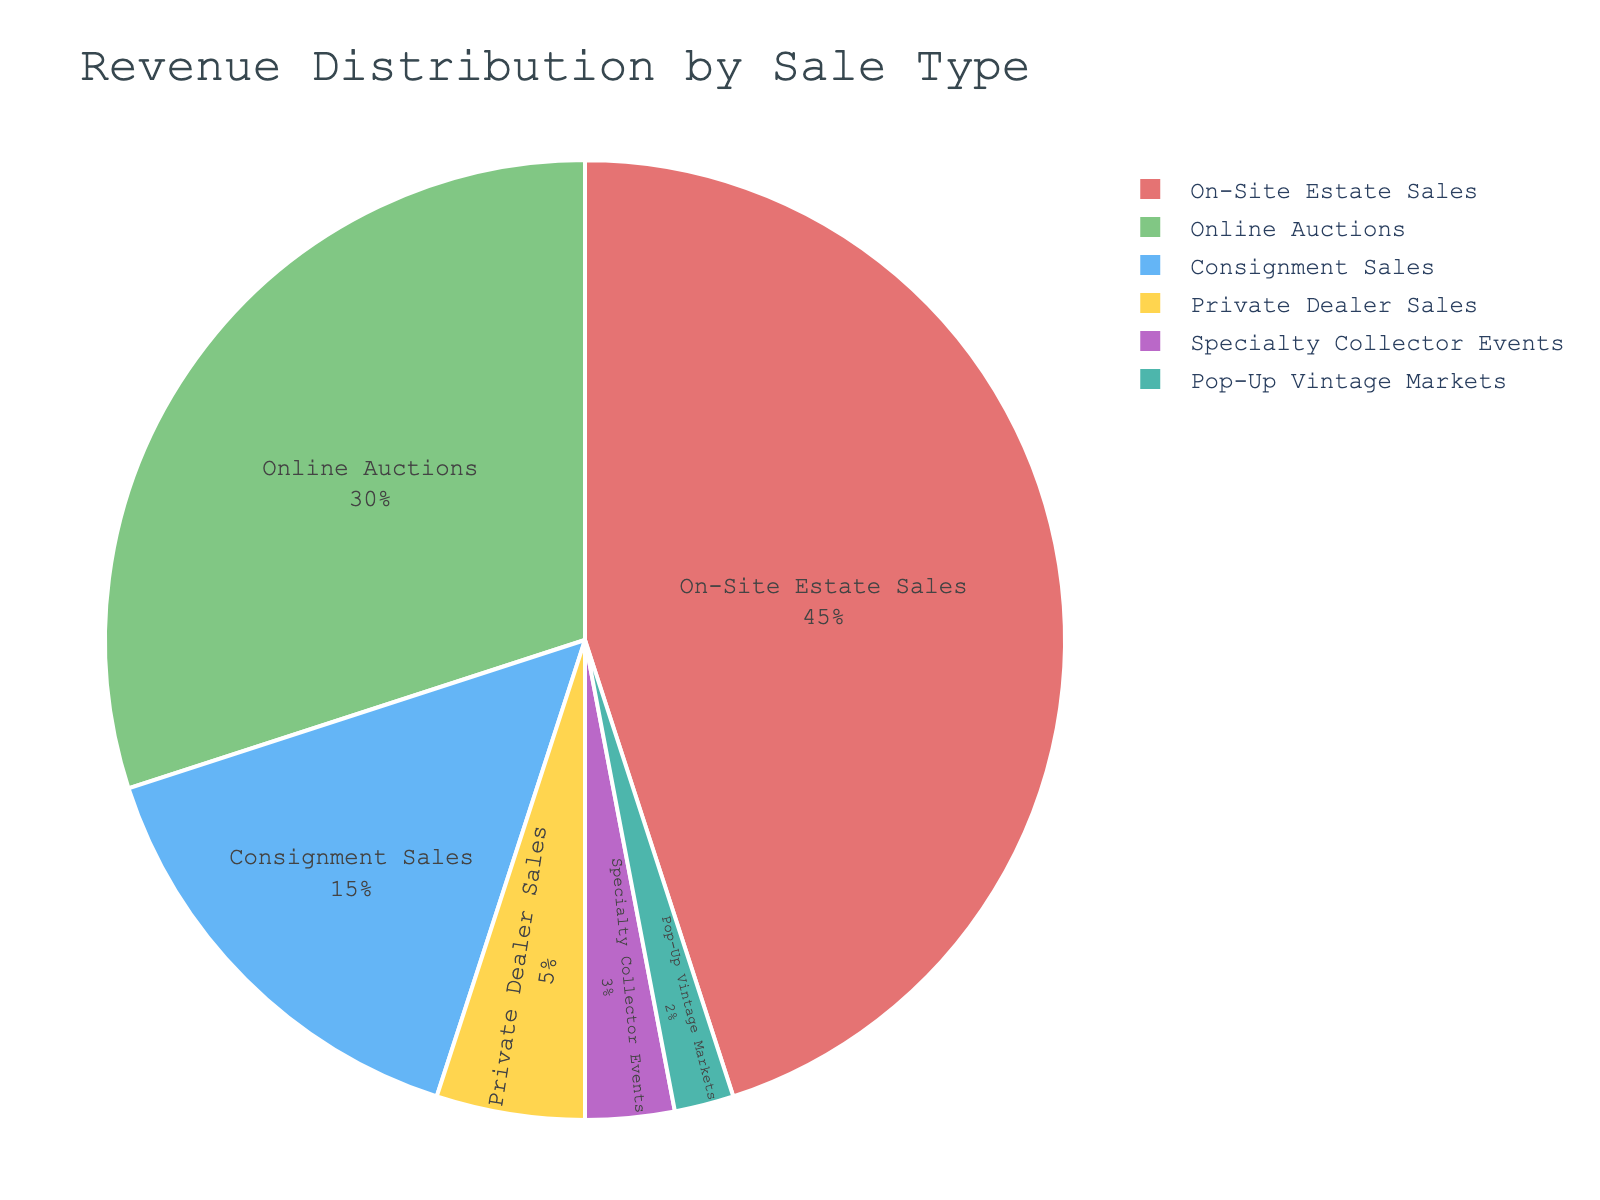Which sale type generates the highest revenue percentage? The figure shows that "On-Site Estate Sales" occupies the largest portion of the pie chart.
Answer: On-Site Estate Sales What is the combined revenue percentage of Consignment Sales and Private Dealer Sales? Consignment Sales accounts for 15% and Private Dealer Sales for 5%. Adding them together: 15% + 5% = 20%.
Answer: 20% Which sale type has a greater revenue percentage, Online Auctions or Specialty Collector Events, and by how much? Online Auctions account for 30%, whereas Specialty Collector Events account for 3%. The difference is 30% - 3% = 27%.
Answer: Online Auctions by 27% How much more revenue percentage do On-Site Estate Sales generate compared to Pop-Up Vintage Markets? On-Site Estate Sales generate 45% and Pop-Up Vintage Markets generate 2%. The difference is 45% - 2% = 43%.
Answer: 43% What is the total revenue percentage of the three smallest revenue sources? The smallest revenue sources are Pop-Up Vintage Markets (2%), Specialty Collector Events (3%), and Private Dealer Sales (5%). Adding them: 2% + 3% + 5% = 10%.
Answer: 10% Which color represents Online Auctions? The segment representing Online Auctions is shaded in green.
Answer: Green If you were to remove the revenue from Specialty Collector Events and Pop-Up Vintage Markets, what would be the remaining total revenue percentage? Specialty Collector Events and Pop-Up Vintage Markets contribute 3% and 2%, respectively. The total percentage is 100%. Removing these two gives: 100% - 3% - 2% = 95%.
Answer: 95% Is the revenue percentage generated by Consignment Sales greater than that of Private Dealer Sales? Consignment Sales generate 15%, while Private Dealer Sales generate 5%. Since 15% is greater than 5%, Consignment Sales has a higher percentage.
Answer: Yes Identify all sale types that have a revenue percentage under 10%. The sale types falling under 10% are Private Dealer Sales (5%), Specialty Collector Events (3%), and Pop-Up Vintage Markets (2%).
Answer: Private Dealer Sales, Specialty Collector Events, Pop-Up Vintage Markets 